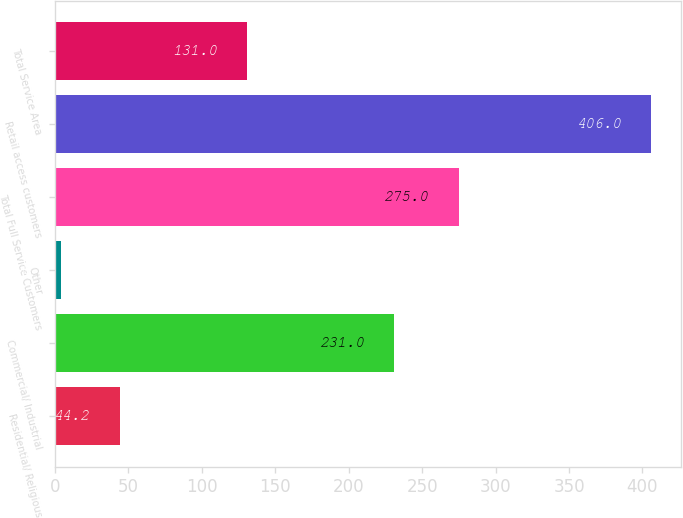<chart> <loc_0><loc_0><loc_500><loc_500><bar_chart><fcel>Residential/ Religious<fcel>Commercial/ Industrial<fcel>Other<fcel>Total Full Service Customers<fcel>Retail access customers<fcel>Total Service Area<nl><fcel>44.2<fcel>231<fcel>4<fcel>275<fcel>406<fcel>131<nl></chart> 